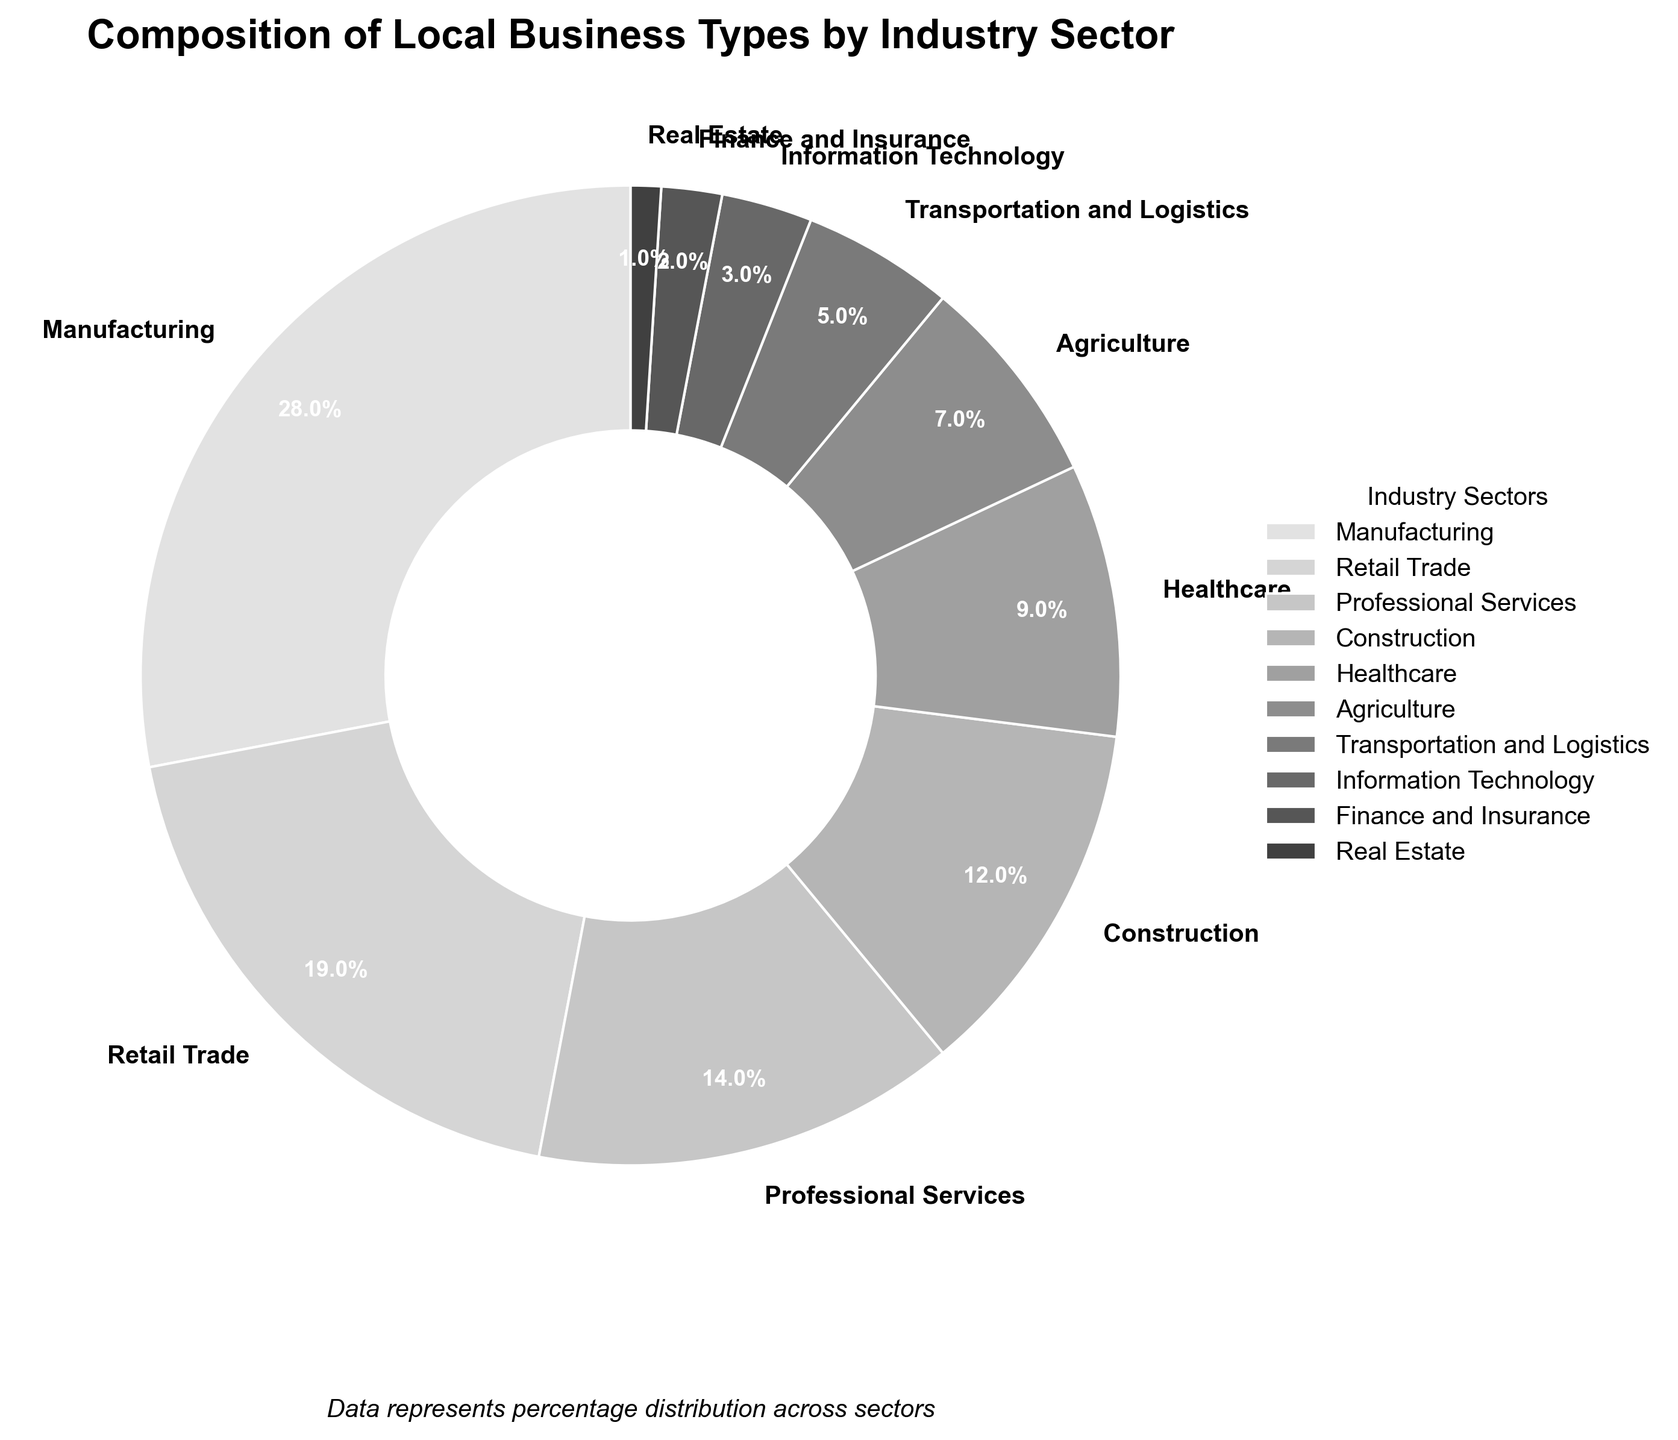What is the sum of the percentages of Manufacturing, Retail Trade, and Professional Services? To find the sum of the percentages, add the values for Manufacturing (28%), Retail Trade (19%), and Professional Services (14%). This gives 28 + 19 + 14 = 61%.
Answer: 61% Which industry sector has the smallest percentage in the pie chart? Observing the pie chart, the sector with the smallest percentage is Real Estate. It shows the smallest slice compared to others, with only 1%.
Answer: Real Estate Is the percentage of Healthcare greater than the sum of percentages of Finance and Insurance, and Real Estate combined? The percentage of Healthcare is 9%. The combined percentage for Finance and Insurance is 2%, and for Real Estate is 1%. Adding them gives 2 + 1 = 3%. Since 9% is greater than 3%, Healthcare is indeed greater than the sum of Finance and Insurance and Real Estate.
Answer: Yes What is the difference in percentage between the largest and smallest industry sectors? The largest sector is Manufacturing at 28%, and the smallest is Real Estate at 1%. The difference is calculated by 28 - 1 = 27%.
Answer: 27% Among Agriculture, Transportation and Logistics, and Information Technology, which one has the highest percentage? Comparing Agriculture (7%), Transportation and Logistics (5%), and Information Technology (3%), Agriculture has the highest percentage.
Answer: Agriculture How many industry sectors have percentages that are at or above 10%? Observing the pie chart, four sectors have percentages at or above 10%: Manufacturing (28%), Retail Trade (19%), Professional Services (14%), and Construction (12%).
Answer: 4 Which two industry sectors combined have a percentage equal to or close to the percentage of Manufacturing? The percentages for Retail Trade (19%) and Construction (12%) sum up to 31%, which is very close to the Manufacturing percentage of 28%.
Answer: Retail Trade and Construction What percentage of the pie chart is represented by sectors with less than 10% each? Sectors with less than 10% each include Healthcare (9%), Agriculture (7%), Transportation and Logistics (5%), Information Technology (3%), Finance and Insurance (2%), and Real Estate (1%). The sum is 9 + 7 + 5 + 3 + 2 + 1 = 27%.
Answer: 27% What industry sectors are represented with a medium shade of grey? The pie chart uses different shades of grey for distinguishing sectors. Sectors like Professional Services and Construction are represented with medium grey shades, not too dark or too light compared to others.
Answer: Professional Services and Construction Is the percentage of Construction higher than the combined percentages of Transportation and Logistics, and Information Technology? Construction has a percentage of 12%. The combined percentage of Transportation and Logistics (5%) and Information Technology (3%) is 5 + 3 = 8%. Since 12% is greater than 8%, Construction’s percentage is higher.
Answer: Yes 